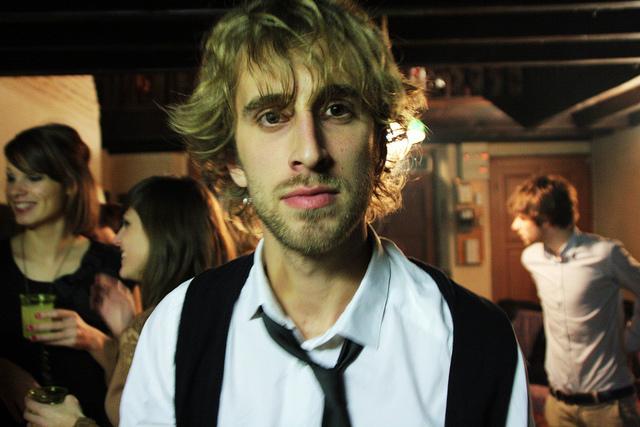Is this man wearing glasses?
Write a very short answer. No. Is the man clean shaven?
Write a very short answer. No. Is the man's tie tight or loose?
Be succinct. Loose. 